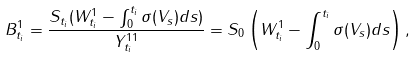<formula> <loc_0><loc_0><loc_500><loc_500>B _ { t _ { i } } ^ { 1 } = \frac { S _ { t _ { i } } ( W _ { t _ { i } } ^ { 1 } - \int _ { 0 } ^ { t _ { i } } { \sigma ( V _ { s } ) d s } ) } { Y _ { t _ { i } } ^ { 1 1 } } = S _ { 0 } \left ( W _ { t _ { i } } ^ { 1 } - \int _ { 0 } ^ { t _ { i } } { \sigma ( V _ { s } ) d s } \right ) ,</formula> 